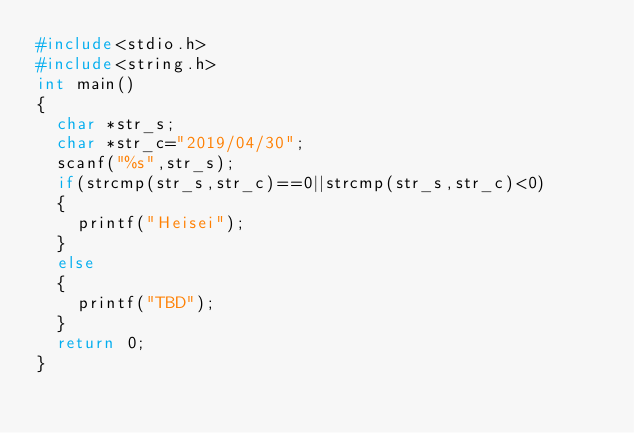Convert code to text. <code><loc_0><loc_0><loc_500><loc_500><_C_>#include<stdio.h>
#include<string.h>
int main()
{
  char *str_s;
  char *str_c="2019/04/30";
  scanf("%s",str_s);
  if(strcmp(str_s,str_c)==0||strcmp(str_s,str_c)<0)
  {
    printf("Heisei");
  }
  else
  {
    printf("TBD");
  }
  return 0;
}
</code> 